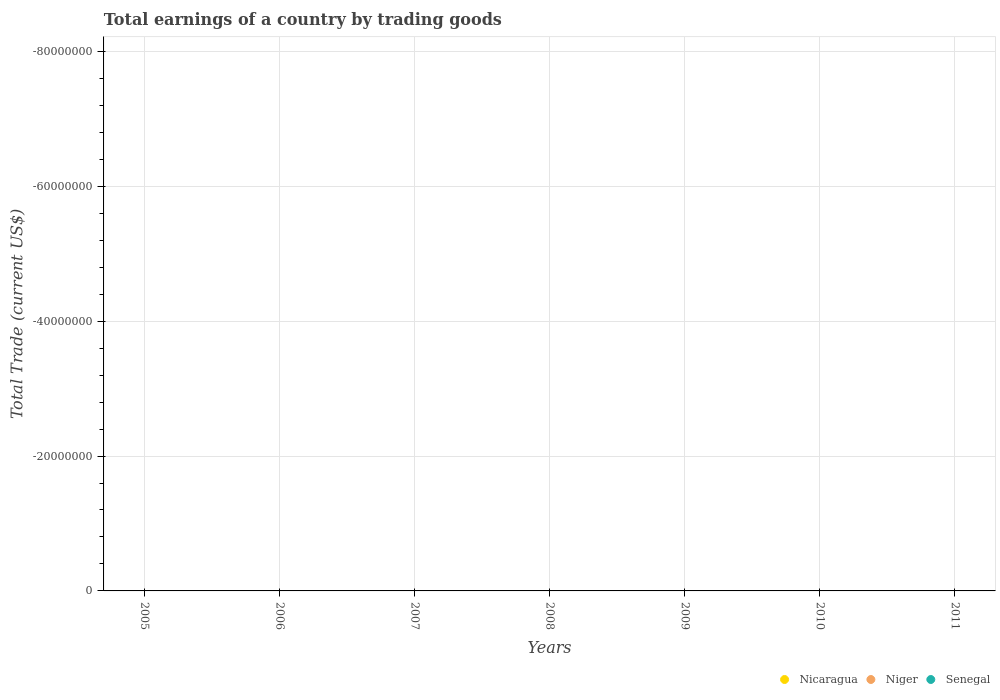How many different coloured dotlines are there?
Provide a short and direct response. 0. Across all years, what is the minimum total earnings in Senegal?
Provide a succinct answer. 0. What is the average total earnings in Niger per year?
Your answer should be very brief. 0. In how many years, is the total earnings in Senegal greater than -24000000 US$?
Provide a succinct answer. 0. Does the total earnings in Nicaragua monotonically increase over the years?
Offer a terse response. No. Is the total earnings in Nicaragua strictly greater than the total earnings in Senegal over the years?
Give a very brief answer. No. Is the total earnings in Niger strictly less than the total earnings in Nicaragua over the years?
Offer a very short reply. No. How many years are there in the graph?
Your answer should be very brief. 7. What is the difference between two consecutive major ticks on the Y-axis?
Offer a very short reply. 2.00e+07. Does the graph contain grids?
Your answer should be compact. Yes. Where does the legend appear in the graph?
Provide a short and direct response. Bottom right. How many legend labels are there?
Provide a short and direct response. 3. How are the legend labels stacked?
Your answer should be compact. Horizontal. What is the title of the graph?
Offer a very short reply. Total earnings of a country by trading goods. Does "Equatorial Guinea" appear as one of the legend labels in the graph?
Give a very brief answer. No. What is the label or title of the X-axis?
Keep it short and to the point. Years. What is the label or title of the Y-axis?
Your response must be concise. Total Trade (current US$). What is the Total Trade (current US$) of Nicaragua in 2005?
Your answer should be very brief. 0. What is the Total Trade (current US$) of Nicaragua in 2006?
Ensure brevity in your answer.  0. What is the Total Trade (current US$) in Niger in 2006?
Offer a very short reply. 0. What is the Total Trade (current US$) in Nicaragua in 2007?
Provide a short and direct response. 0. What is the Total Trade (current US$) of Niger in 2009?
Provide a short and direct response. 0. What is the Total Trade (current US$) of Nicaragua in 2010?
Keep it short and to the point. 0. What is the Total Trade (current US$) in Niger in 2010?
Provide a short and direct response. 0. What is the Total Trade (current US$) of Nicaragua in 2011?
Provide a short and direct response. 0. What is the Total Trade (current US$) of Niger in 2011?
Your response must be concise. 0. What is the Total Trade (current US$) in Senegal in 2011?
Your answer should be compact. 0. What is the total Total Trade (current US$) in Niger in the graph?
Your answer should be compact. 0. What is the average Total Trade (current US$) in Nicaragua per year?
Ensure brevity in your answer.  0. What is the average Total Trade (current US$) in Niger per year?
Offer a very short reply. 0. 